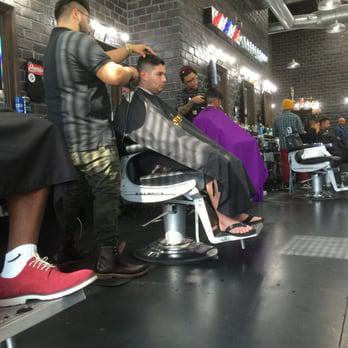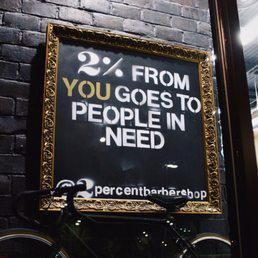The first image is the image on the left, the second image is the image on the right. Given the left and right images, does the statement "Black barber chairs are empty in one image." hold true? Answer yes or no. No. 